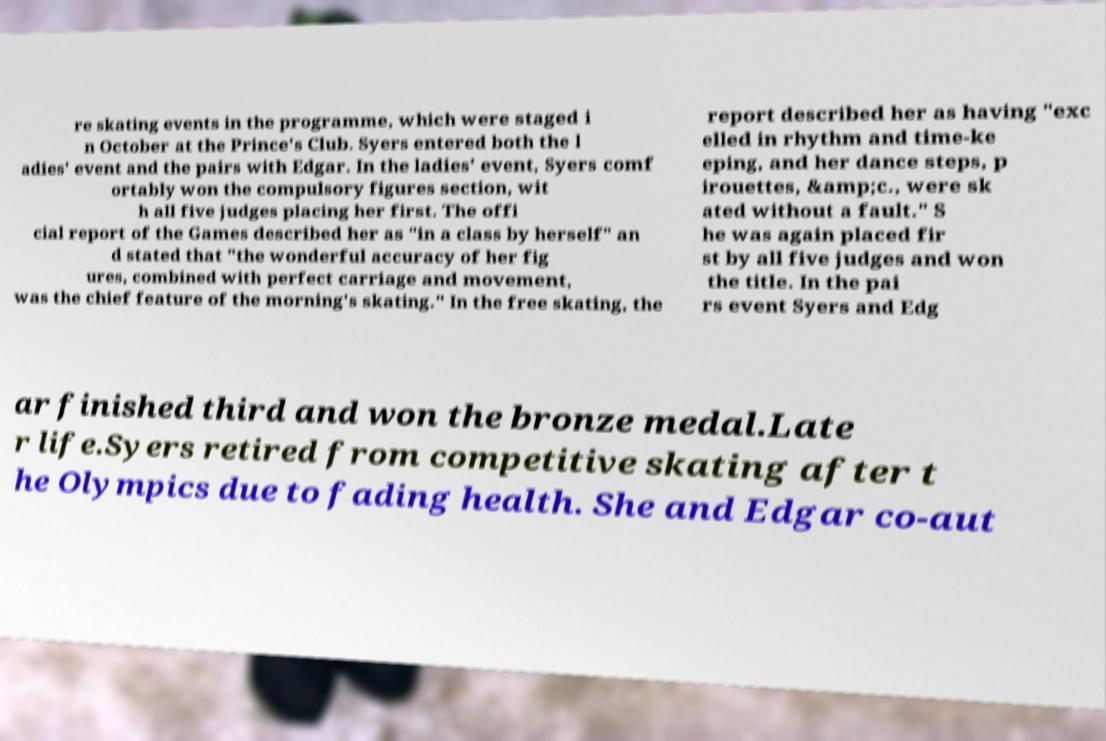Can you accurately transcribe the text from the provided image for me? re skating events in the programme, which were staged i n October at the Prince's Club. Syers entered both the l adies' event and the pairs with Edgar. In the ladies' event, Syers comf ortably won the compulsory figures section, wit h all five judges placing her first. The offi cial report of the Games described her as "in a class by herself" an d stated that "the wonderful accuracy of her fig ures, combined with perfect carriage and movement, was the chief feature of the morning's skating." In the free skating, the report described her as having "exc elled in rhythm and time-ke eping, and her dance steps, p irouettes, &amp;c., were sk ated without a fault." S he was again placed fir st by all five judges and won the title. In the pai rs event Syers and Edg ar finished third and won the bronze medal.Late r life.Syers retired from competitive skating after t he Olympics due to fading health. She and Edgar co-aut 